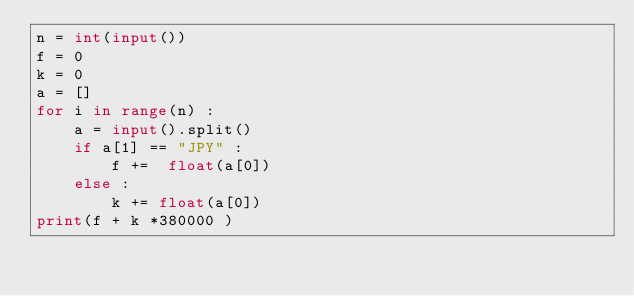Convert code to text. <code><loc_0><loc_0><loc_500><loc_500><_Python_>n = int(input())
f = 0
k = 0
a = []
for i in range(n) :
    a = input().split()
    if a[1] == "JPY" :
        f +=  float(a[0])
    else :
        k += float(a[0])
print(f + k *380000 )
</code> 